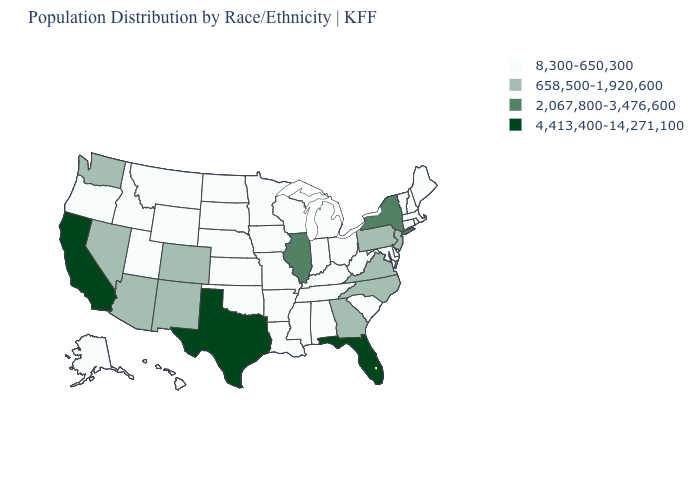Which states have the lowest value in the USA?
Be succinct. Alabama, Alaska, Arkansas, Connecticut, Delaware, Hawaii, Idaho, Indiana, Iowa, Kansas, Kentucky, Louisiana, Maine, Maryland, Massachusetts, Michigan, Minnesota, Mississippi, Missouri, Montana, Nebraska, New Hampshire, North Dakota, Ohio, Oklahoma, Oregon, Rhode Island, South Carolina, South Dakota, Tennessee, Utah, Vermont, West Virginia, Wisconsin, Wyoming. Name the states that have a value in the range 658,500-1,920,600?
Concise answer only. Arizona, Colorado, Georgia, Nevada, New Jersey, New Mexico, North Carolina, Pennsylvania, Virginia, Washington. Which states hav the highest value in the West?
Give a very brief answer. California. What is the lowest value in the USA?
Quick response, please. 8,300-650,300. What is the value of New Hampshire?
Keep it brief. 8,300-650,300. Name the states that have a value in the range 8,300-650,300?
Give a very brief answer. Alabama, Alaska, Arkansas, Connecticut, Delaware, Hawaii, Idaho, Indiana, Iowa, Kansas, Kentucky, Louisiana, Maine, Maryland, Massachusetts, Michigan, Minnesota, Mississippi, Missouri, Montana, Nebraska, New Hampshire, North Dakota, Ohio, Oklahoma, Oregon, Rhode Island, South Carolina, South Dakota, Tennessee, Utah, Vermont, West Virginia, Wisconsin, Wyoming. Does the map have missing data?
Quick response, please. No. Name the states that have a value in the range 658,500-1,920,600?
Give a very brief answer. Arizona, Colorado, Georgia, Nevada, New Jersey, New Mexico, North Carolina, Pennsylvania, Virginia, Washington. What is the highest value in states that border Alabama?
Be succinct. 4,413,400-14,271,100. Does Maine have the lowest value in the Northeast?
Keep it brief. Yes. Does Oklahoma have the lowest value in the USA?
Quick response, please. Yes. Among the states that border Wisconsin , does Minnesota have the lowest value?
Concise answer only. Yes. What is the highest value in states that border West Virginia?
Concise answer only. 658,500-1,920,600. What is the value of Oklahoma?
Answer briefly. 8,300-650,300. Name the states that have a value in the range 8,300-650,300?
Give a very brief answer. Alabama, Alaska, Arkansas, Connecticut, Delaware, Hawaii, Idaho, Indiana, Iowa, Kansas, Kentucky, Louisiana, Maine, Maryland, Massachusetts, Michigan, Minnesota, Mississippi, Missouri, Montana, Nebraska, New Hampshire, North Dakota, Ohio, Oklahoma, Oregon, Rhode Island, South Carolina, South Dakota, Tennessee, Utah, Vermont, West Virginia, Wisconsin, Wyoming. 